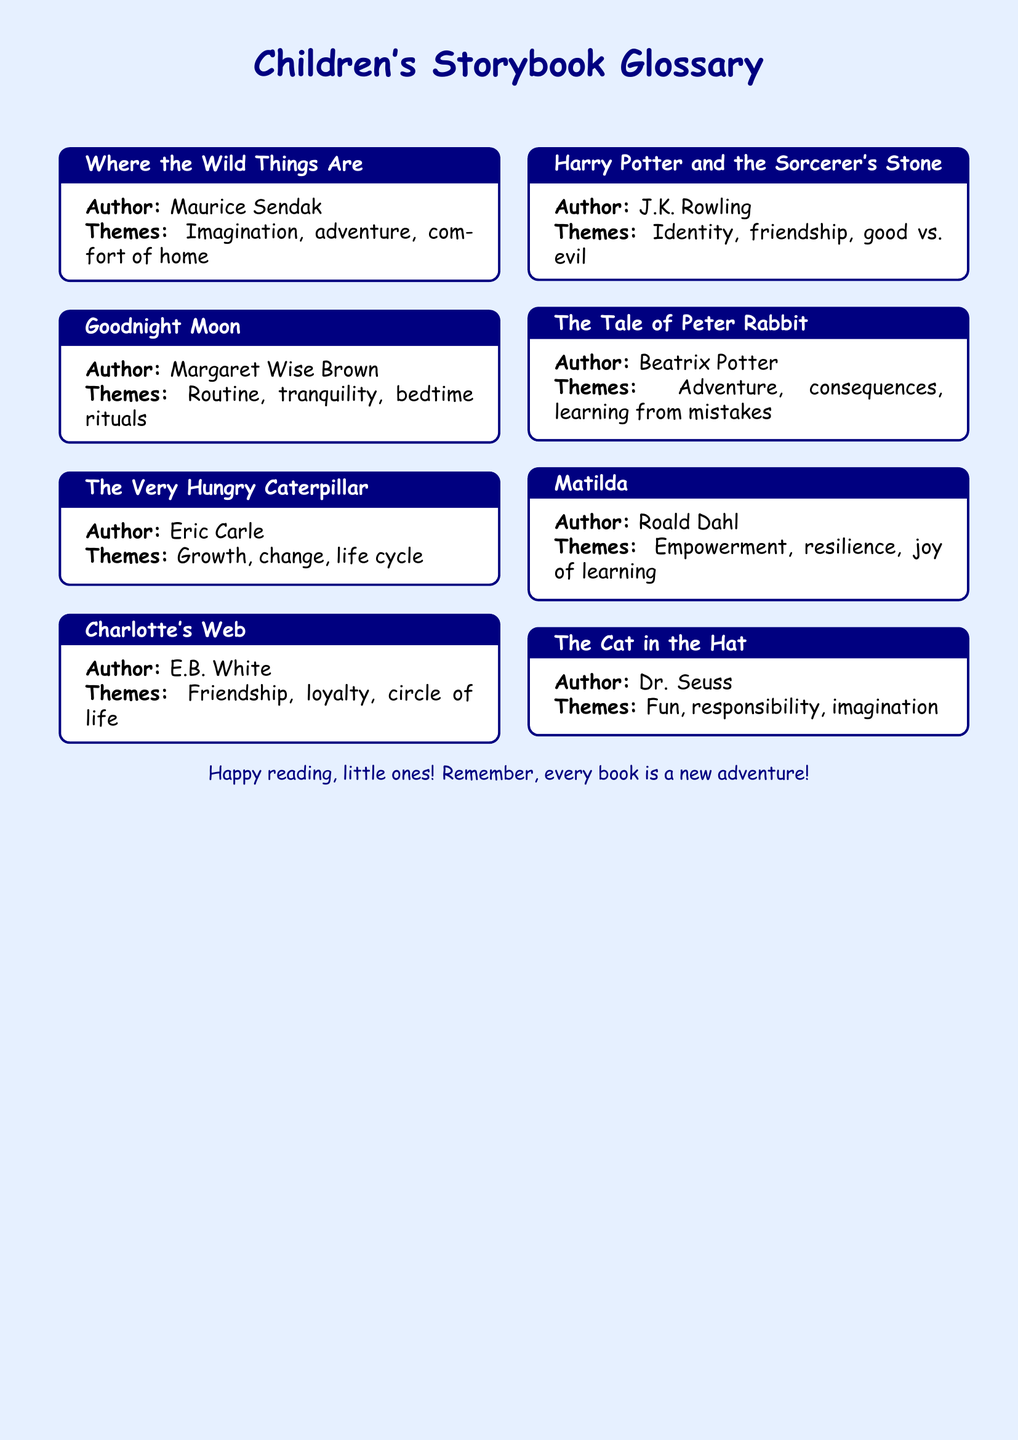What is the title of the book by Maurice Sendak? The title of the book is found in the first entry, where it mentions the work by the author.
Answer: Where the Wild Things Are What is the theme of "Goodnight Moon"? The theme is stated in the box for "Goodnight Moon," which highlights its main ideas clearly.
Answer: Routine, tranquility, bedtime rituals Who is the author of "The Very Hungry Caterpillar"? This is retrieved from the entry where the author is specifically listed for the book.
Answer: Eric Carle What themes are explored in "Charlotte's Web"? The themes are outlined in the corresponding section for "Charlotte's Web."
Answer: Friendship, loyalty, circle of life How many themes are listed for "Harry Potter and the Sorcerer's Stone"? The number of themes can be counted from the entry for "Harry Potter and the Sorcerer's Stone."
Answer: Three Which book features the theme of empowerment? The specific theme is linked to "Matilda" in the entry about that book.
Answer: Matilda What is the common genre of the books listed in the document? The books all fall under children's literature, which is inferred from the document's title and content focus.
Answer: Children's literature What color is used for backgrounds in the document? The background color can be found in the document layout settings.
Answer: Light blue 